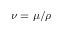Convert formula to latex. <formula><loc_0><loc_0><loc_500><loc_500>\nu = \mu / \rho</formula> 